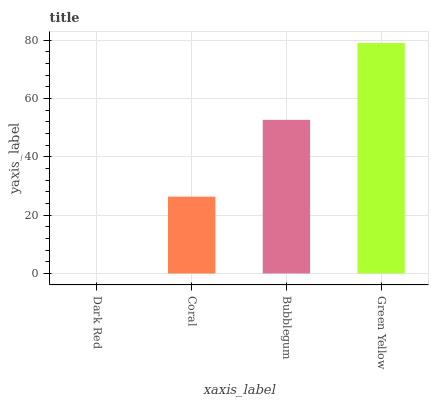Is Dark Red the minimum?
Answer yes or no. Yes. Is Green Yellow the maximum?
Answer yes or no. Yes. Is Coral the minimum?
Answer yes or no. No. Is Coral the maximum?
Answer yes or no. No. Is Coral greater than Dark Red?
Answer yes or no. Yes. Is Dark Red less than Coral?
Answer yes or no. Yes. Is Dark Red greater than Coral?
Answer yes or no. No. Is Coral less than Dark Red?
Answer yes or no. No. Is Bubblegum the high median?
Answer yes or no. Yes. Is Coral the low median?
Answer yes or no. Yes. Is Green Yellow the high median?
Answer yes or no. No. Is Green Yellow the low median?
Answer yes or no. No. 